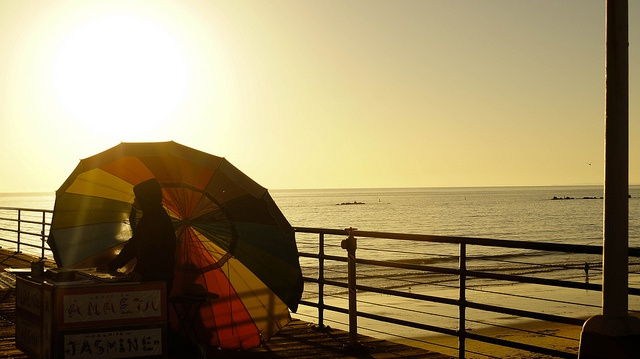Describe the objects in this image and their specific colors. I can see umbrella in khaki, black, maroon, and olive tones and people in khaki, black, maroon, and olive tones in this image. 